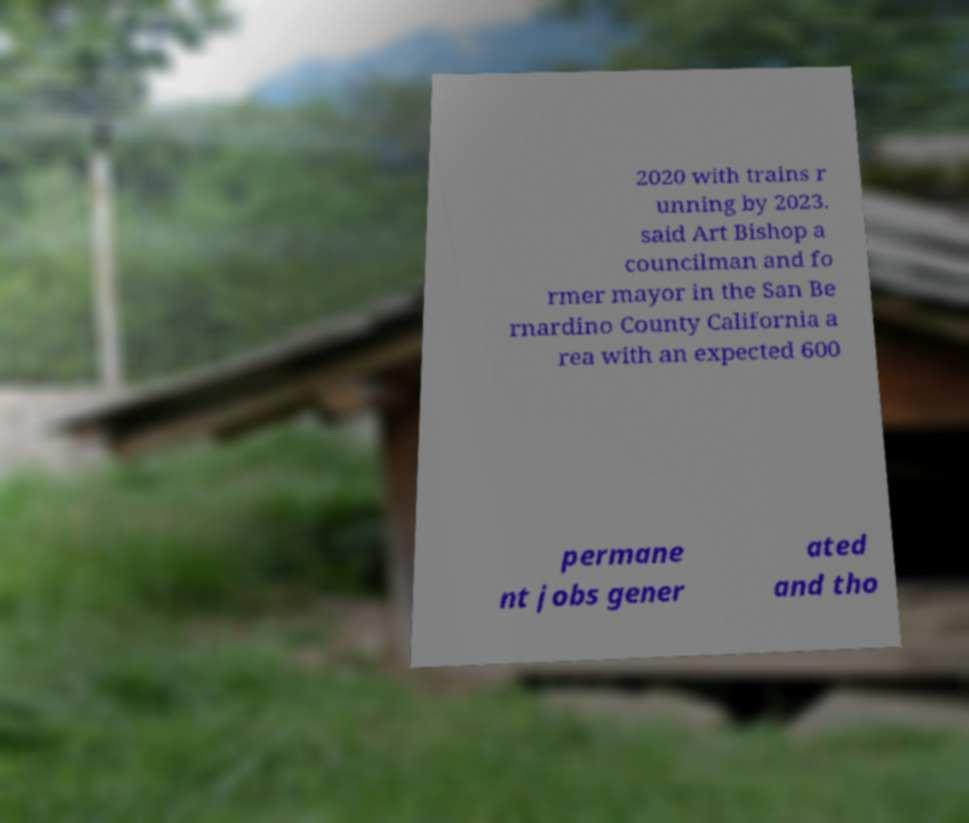I need the written content from this picture converted into text. Can you do that? 2020 with trains r unning by 2023. said Art Bishop a councilman and fo rmer mayor in the San Be rnardino County California a rea with an expected 600 permane nt jobs gener ated and tho 